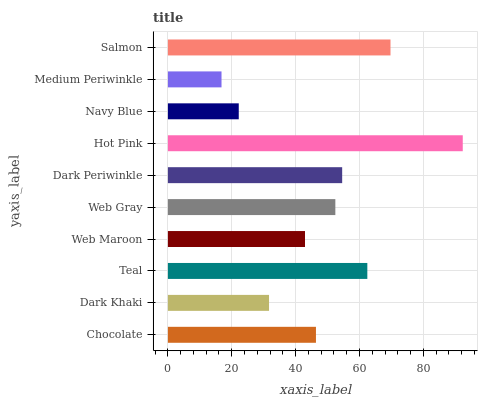Is Medium Periwinkle the minimum?
Answer yes or no. Yes. Is Hot Pink the maximum?
Answer yes or no. Yes. Is Dark Khaki the minimum?
Answer yes or no. No. Is Dark Khaki the maximum?
Answer yes or no. No. Is Chocolate greater than Dark Khaki?
Answer yes or no. Yes. Is Dark Khaki less than Chocolate?
Answer yes or no. Yes. Is Dark Khaki greater than Chocolate?
Answer yes or no. No. Is Chocolate less than Dark Khaki?
Answer yes or no. No. Is Web Gray the high median?
Answer yes or no. Yes. Is Chocolate the low median?
Answer yes or no. Yes. Is Salmon the high median?
Answer yes or no. No. Is Teal the low median?
Answer yes or no. No. 